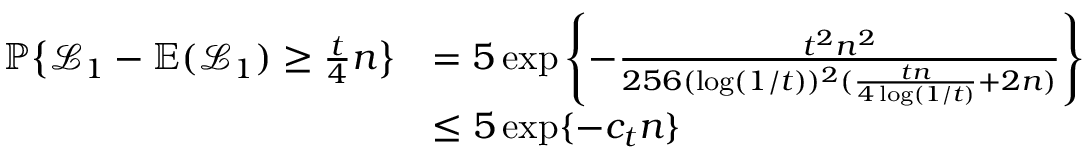Convert formula to latex. <formula><loc_0><loc_0><loc_500><loc_500>\begin{array} { r l } { { \mathbb { P } } \left \{ \mathcal { L } _ { 1 } - \mathbb { E } ( \mathcal { L } _ { 1 } ) \geq \frac { t } { 4 } n \right \} } & { = 5 \exp \left \{ - \frac { t ^ { 2 } n ^ { 2 } } { 2 5 6 ( \log ( 1 / t ) ) ^ { 2 } ( \frac { t n } { 4 \log ( 1 / t ) } + 2 n ) } \right \} } \\ & { \leq 5 \exp \{ - c _ { t } n \} } \end{array}</formula> 